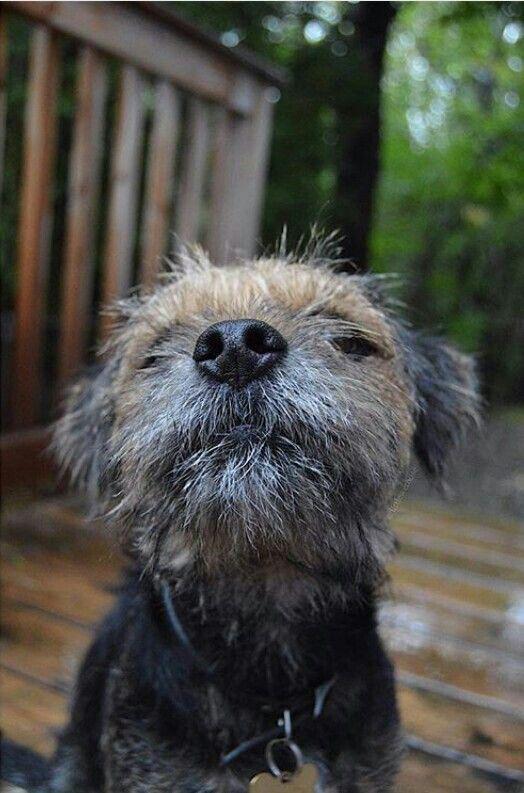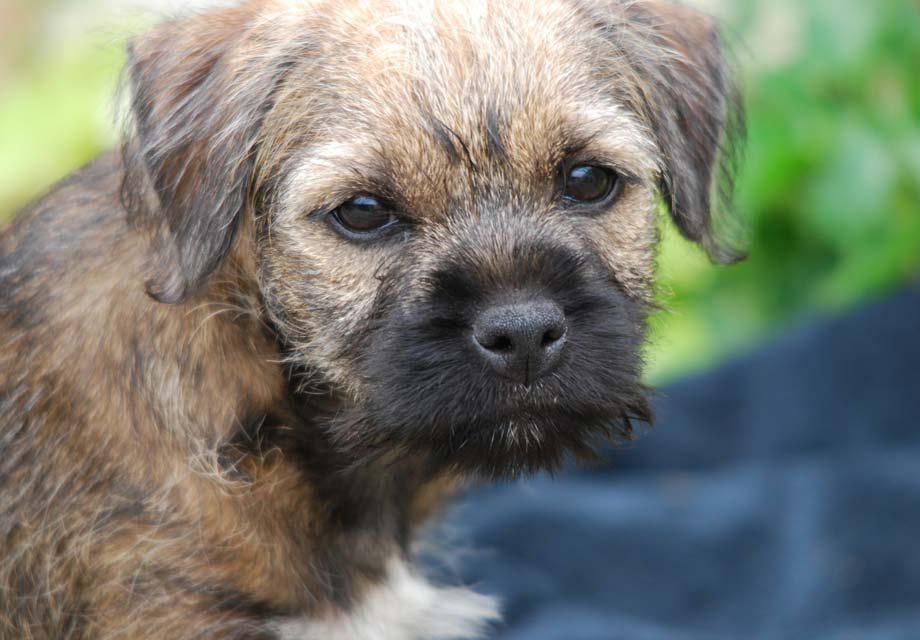The first image is the image on the left, the second image is the image on the right. Analyze the images presented: Is the assertion "One dog's tongue is hanging out of its mouth." valid? Answer yes or no. No. The first image is the image on the left, the second image is the image on the right. Evaluate the accuracy of this statement regarding the images: "One dog is sitting in the grass.". Is it true? Answer yes or no. No. 